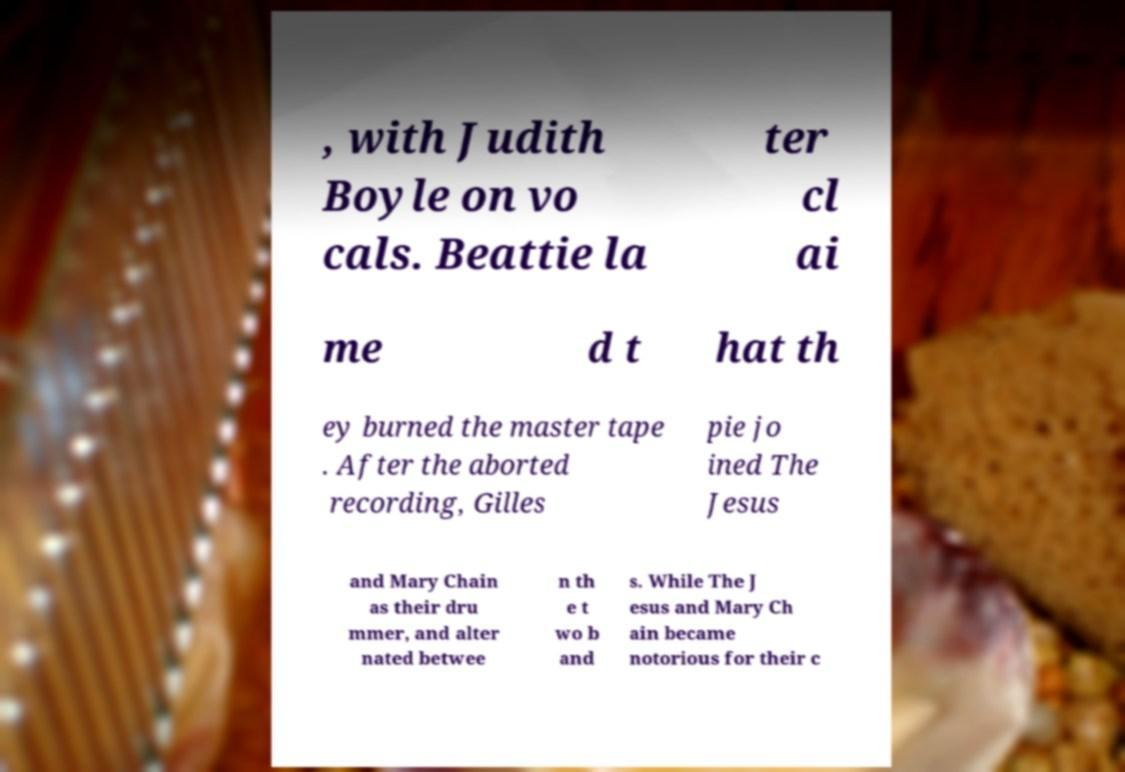Could you assist in decoding the text presented in this image and type it out clearly? , with Judith Boyle on vo cals. Beattie la ter cl ai me d t hat th ey burned the master tape . After the aborted recording, Gilles pie jo ined The Jesus and Mary Chain as their dru mmer, and alter nated betwee n th e t wo b and s. While The J esus and Mary Ch ain became notorious for their c 